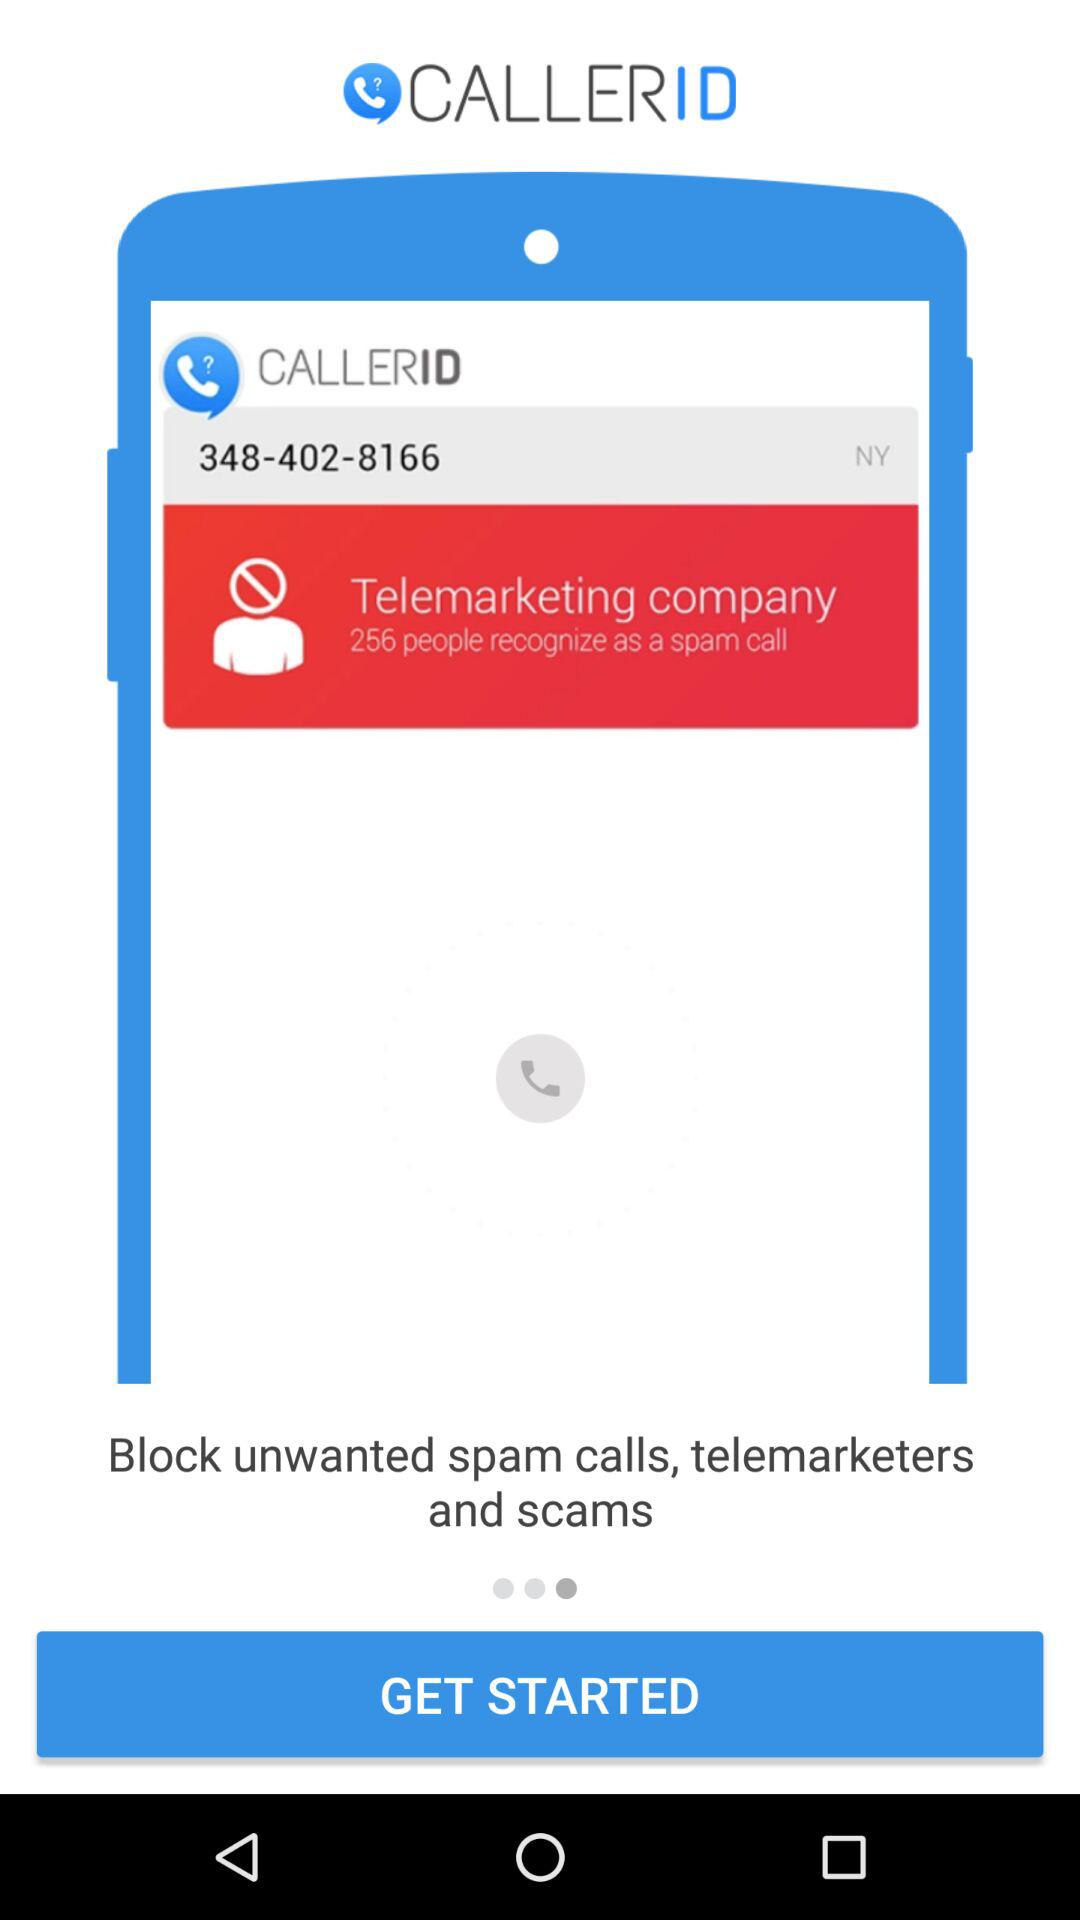How many people recognize the call as spam? There are 256 people who recognize the call as spam. 